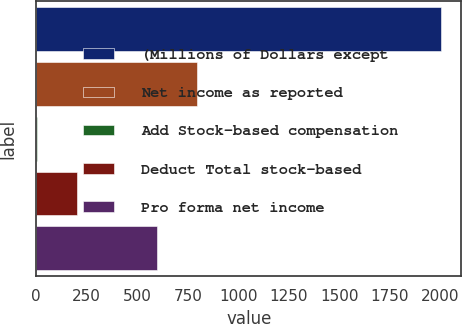<chart> <loc_0><loc_0><loc_500><loc_500><bar_chart><fcel>(Millions of Dollars except<fcel>Net income as reported<fcel>Add Stock-based compensation<fcel>Deduct Total stock-based<fcel>Pro forma net income<nl><fcel>2003<fcel>798<fcel>3<fcel>203<fcel>598<nl></chart> 